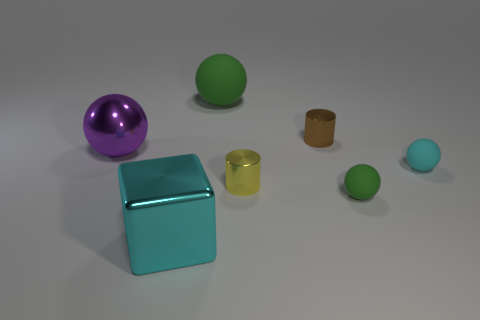What material is the large thing that is both to the left of the big green ball and to the right of the big shiny sphere?
Offer a terse response. Metal. Is the green sphere behind the large purple metallic sphere made of the same material as the large cube in front of the tiny cyan matte sphere?
Keep it short and to the point. No. Are there the same number of matte things that are behind the small yellow cylinder and green metal cubes?
Make the answer very short. No. Is there another tiny thing that has the same material as the tiny cyan thing?
Ensure brevity in your answer.  Yes. Is the shape of the cyan thing that is right of the brown metal cylinder the same as the object on the left side of the big cyan metal thing?
Keep it short and to the point. Yes. Are any rubber spheres visible?
Your response must be concise. Yes. What color is the rubber sphere that is the same size as the metallic ball?
Keep it short and to the point. Green. How many other things have the same shape as the brown metal thing?
Offer a terse response. 1. Is the tiny cylinder behind the shiny sphere made of the same material as the tiny cyan object?
Provide a succinct answer. No. How many balls are tiny green matte objects or purple things?
Your answer should be very brief. 2. 